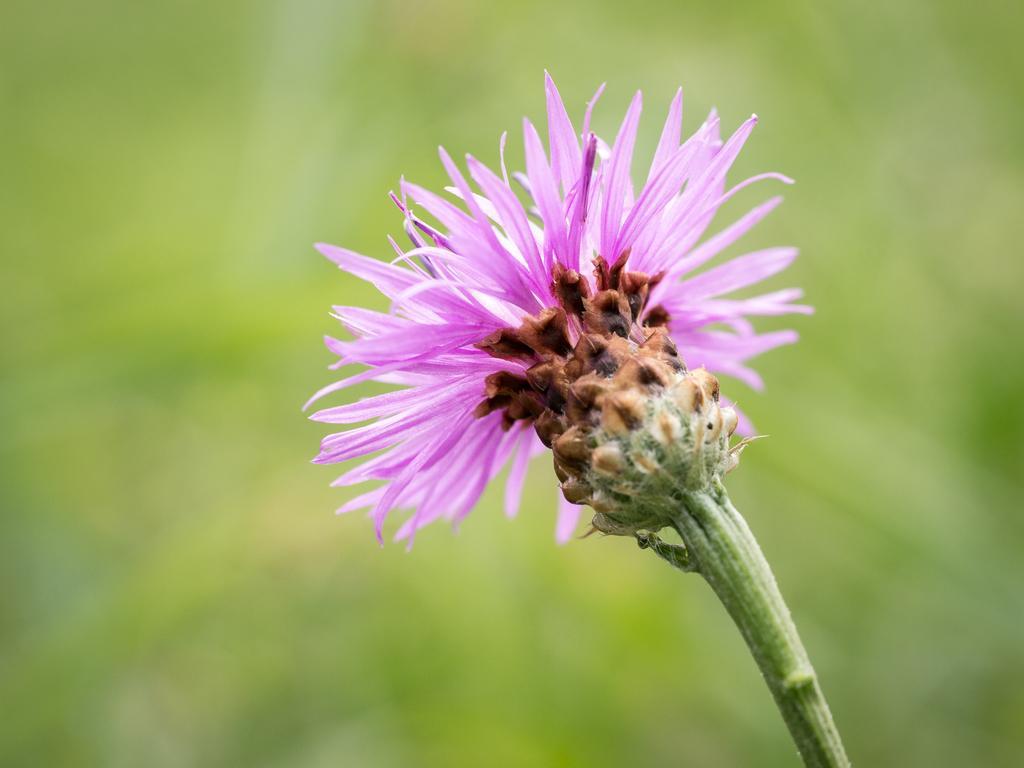Can you describe this image briefly? In the picture we can see a flower which is in pink color and the background image is blur. 